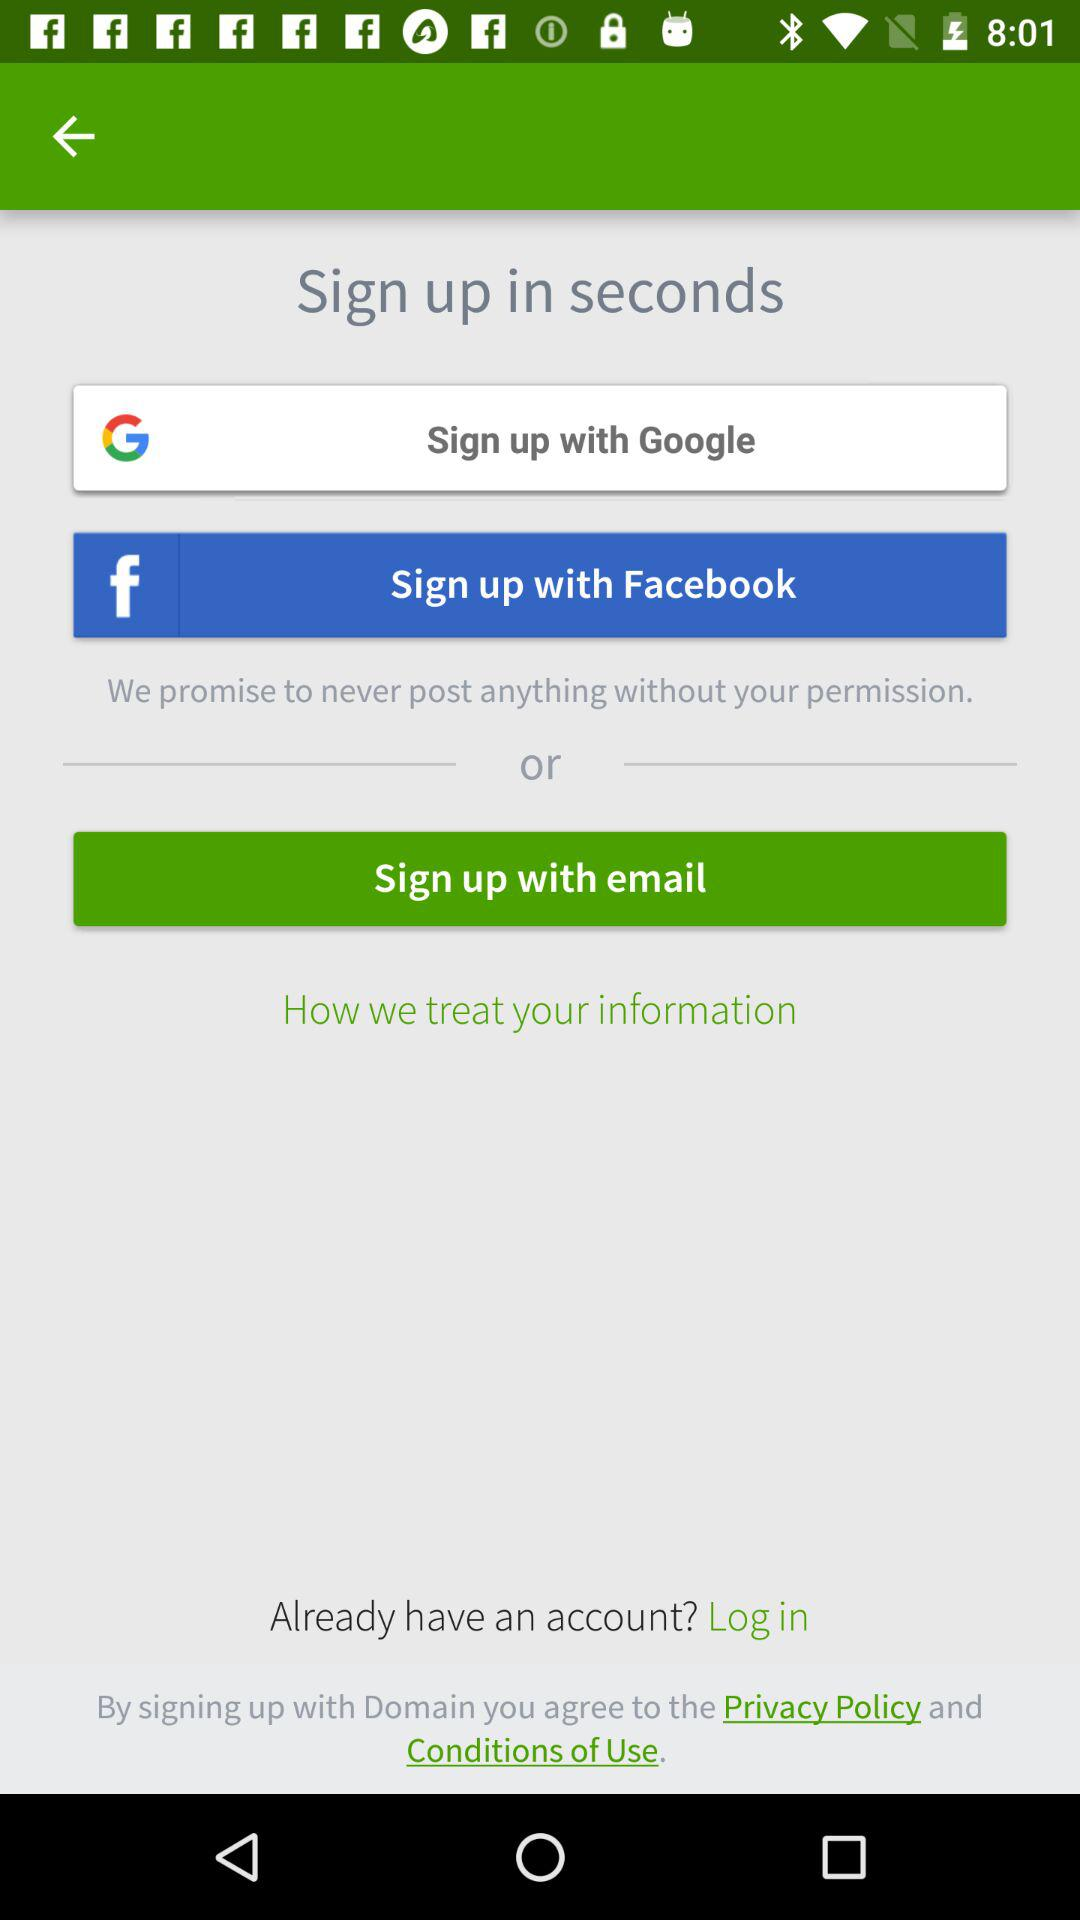What accounts can I use to sign up? You can use "Google", "Facebook" and "email" accounts to sign up. 